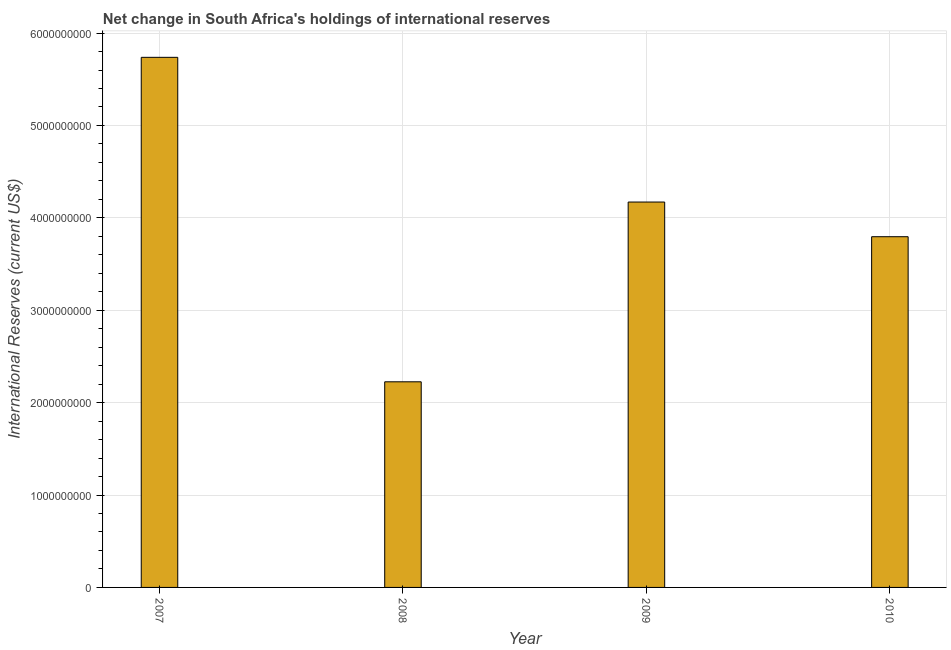Does the graph contain any zero values?
Keep it short and to the point. No. Does the graph contain grids?
Provide a succinct answer. Yes. What is the title of the graph?
Provide a succinct answer. Net change in South Africa's holdings of international reserves. What is the label or title of the X-axis?
Give a very brief answer. Year. What is the label or title of the Y-axis?
Ensure brevity in your answer.  International Reserves (current US$). What is the reserves and related items in 2008?
Offer a terse response. 2.23e+09. Across all years, what is the maximum reserves and related items?
Provide a succinct answer. 5.74e+09. Across all years, what is the minimum reserves and related items?
Offer a very short reply. 2.23e+09. What is the sum of the reserves and related items?
Provide a succinct answer. 1.59e+1. What is the difference between the reserves and related items in 2007 and 2008?
Your answer should be compact. 3.51e+09. What is the average reserves and related items per year?
Provide a succinct answer. 3.98e+09. What is the median reserves and related items?
Give a very brief answer. 3.98e+09. What is the ratio of the reserves and related items in 2008 to that in 2009?
Offer a very short reply. 0.53. Is the difference between the reserves and related items in 2008 and 2010 greater than the difference between any two years?
Provide a succinct answer. No. What is the difference between the highest and the second highest reserves and related items?
Give a very brief answer. 1.57e+09. Is the sum of the reserves and related items in 2009 and 2010 greater than the maximum reserves and related items across all years?
Keep it short and to the point. Yes. What is the difference between the highest and the lowest reserves and related items?
Offer a very short reply. 3.51e+09. In how many years, is the reserves and related items greater than the average reserves and related items taken over all years?
Provide a succinct answer. 2. How many bars are there?
Your answer should be very brief. 4. How many years are there in the graph?
Provide a short and direct response. 4. What is the difference between two consecutive major ticks on the Y-axis?
Offer a very short reply. 1.00e+09. Are the values on the major ticks of Y-axis written in scientific E-notation?
Provide a succinct answer. No. What is the International Reserves (current US$) of 2007?
Give a very brief answer. 5.74e+09. What is the International Reserves (current US$) in 2008?
Keep it short and to the point. 2.23e+09. What is the International Reserves (current US$) of 2009?
Offer a very short reply. 4.17e+09. What is the International Reserves (current US$) in 2010?
Your answer should be compact. 3.80e+09. What is the difference between the International Reserves (current US$) in 2007 and 2008?
Provide a succinct answer. 3.51e+09. What is the difference between the International Reserves (current US$) in 2007 and 2009?
Provide a short and direct response. 1.57e+09. What is the difference between the International Reserves (current US$) in 2007 and 2010?
Keep it short and to the point. 1.94e+09. What is the difference between the International Reserves (current US$) in 2008 and 2009?
Keep it short and to the point. -1.95e+09. What is the difference between the International Reserves (current US$) in 2008 and 2010?
Keep it short and to the point. -1.57e+09. What is the difference between the International Reserves (current US$) in 2009 and 2010?
Offer a terse response. 3.75e+08. What is the ratio of the International Reserves (current US$) in 2007 to that in 2008?
Ensure brevity in your answer.  2.58. What is the ratio of the International Reserves (current US$) in 2007 to that in 2009?
Your answer should be compact. 1.38. What is the ratio of the International Reserves (current US$) in 2007 to that in 2010?
Ensure brevity in your answer.  1.51. What is the ratio of the International Reserves (current US$) in 2008 to that in 2009?
Your response must be concise. 0.53. What is the ratio of the International Reserves (current US$) in 2008 to that in 2010?
Offer a terse response. 0.59. What is the ratio of the International Reserves (current US$) in 2009 to that in 2010?
Offer a terse response. 1.1. 